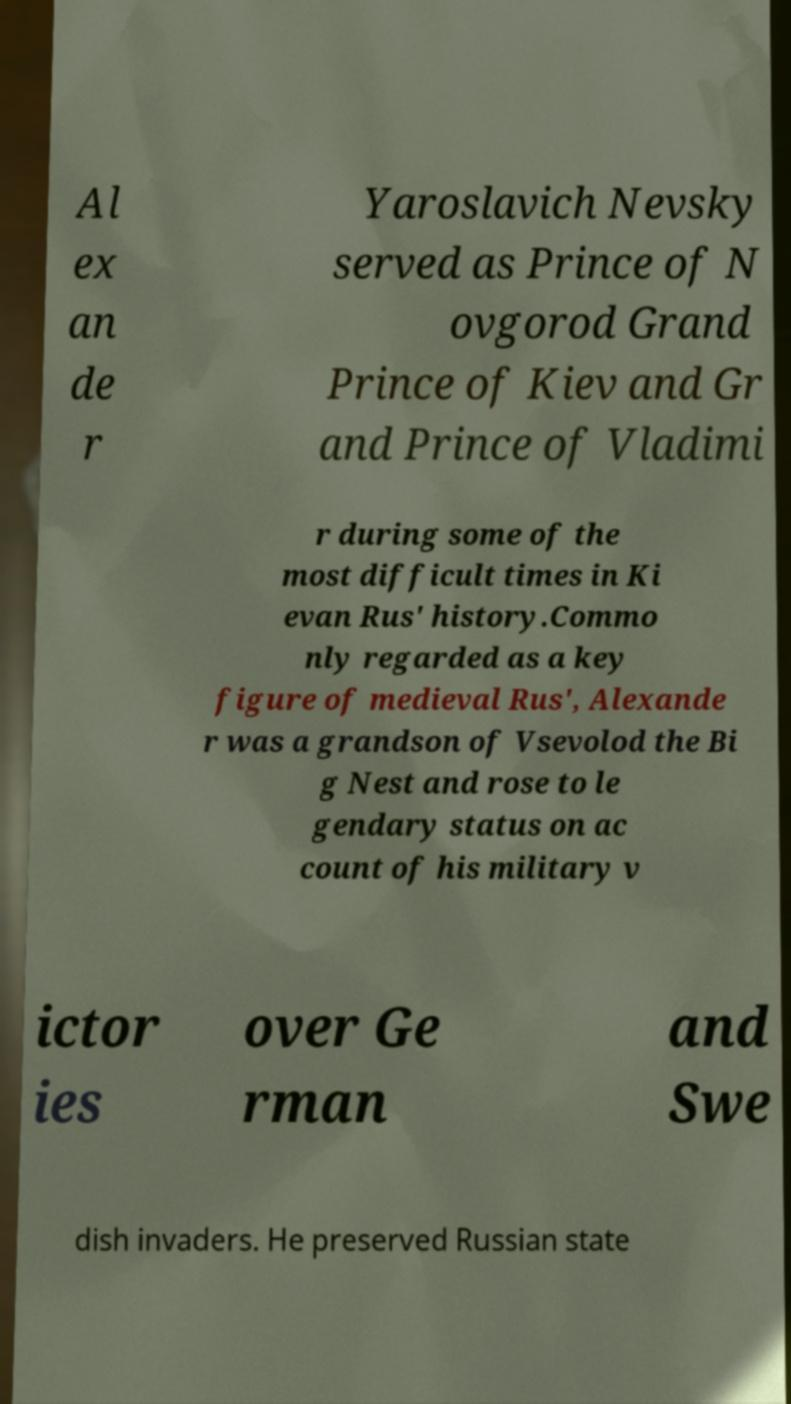Could you extract and type out the text from this image? Al ex an de r Yaroslavich Nevsky served as Prince of N ovgorod Grand Prince of Kiev and Gr and Prince of Vladimi r during some of the most difficult times in Ki evan Rus' history.Commo nly regarded as a key figure of medieval Rus', Alexande r was a grandson of Vsevolod the Bi g Nest and rose to le gendary status on ac count of his military v ictor ies over Ge rman and Swe dish invaders. He preserved Russian state 